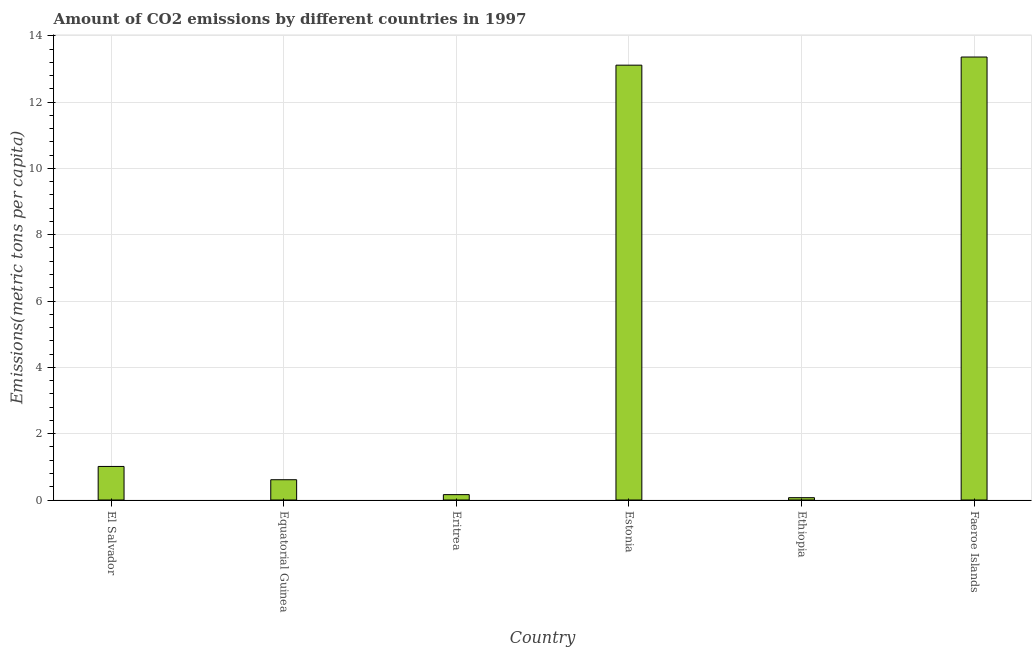What is the title of the graph?
Keep it short and to the point. Amount of CO2 emissions by different countries in 1997. What is the label or title of the X-axis?
Give a very brief answer. Country. What is the label or title of the Y-axis?
Your response must be concise. Emissions(metric tons per capita). What is the amount of co2 emissions in Estonia?
Keep it short and to the point. 13.11. Across all countries, what is the maximum amount of co2 emissions?
Your answer should be compact. 13.36. Across all countries, what is the minimum amount of co2 emissions?
Your answer should be compact. 0.07. In which country was the amount of co2 emissions maximum?
Provide a succinct answer. Faeroe Islands. In which country was the amount of co2 emissions minimum?
Provide a short and direct response. Ethiopia. What is the sum of the amount of co2 emissions?
Offer a terse response. 28.33. What is the difference between the amount of co2 emissions in Estonia and Ethiopia?
Provide a succinct answer. 13.04. What is the average amount of co2 emissions per country?
Offer a very short reply. 4.72. What is the median amount of co2 emissions?
Ensure brevity in your answer.  0.81. What is the ratio of the amount of co2 emissions in Estonia to that in Faeroe Islands?
Your answer should be compact. 0.98. Is the amount of co2 emissions in Equatorial Guinea less than that in Faeroe Islands?
Your response must be concise. Yes. What is the difference between the highest and the second highest amount of co2 emissions?
Ensure brevity in your answer.  0.25. Is the sum of the amount of co2 emissions in Eritrea and Estonia greater than the maximum amount of co2 emissions across all countries?
Your answer should be compact. No. What is the difference between the highest and the lowest amount of co2 emissions?
Your answer should be compact. 13.29. How many bars are there?
Offer a very short reply. 6. Are all the bars in the graph horizontal?
Ensure brevity in your answer.  No. How many countries are there in the graph?
Your response must be concise. 6. What is the difference between two consecutive major ticks on the Y-axis?
Your answer should be compact. 2. What is the Emissions(metric tons per capita) of El Salvador?
Give a very brief answer. 1.01. What is the Emissions(metric tons per capita) in Equatorial Guinea?
Offer a terse response. 0.61. What is the Emissions(metric tons per capita) of Eritrea?
Provide a succinct answer. 0.16. What is the Emissions(metric tons per capita) in Estonia?
Your answer should be compact. 13.11. What is the Emissions(metric tons per capita) of Ethiopia?
Your response must be concise. 0.07. What is the Emissions(metric tons per capita) of Faeroe Islands?
Keep it short and to the point. 13.36. What is the difference between the Emissions(metric tons per capita) in El Salvador and Equatorial Guinea?
Your response must be concise. 0.4. What is the difference between the Emissions(metric tons per capita) in El Salvador and Eritrea?
Your answer should be very brief. 0.85. What is the difference between the Emissions(metric tons per capita) in El Salvador and Estonia?
Give a very brief answer. -12.1. What is the difference between the Emissions(metric tons per capita) in El Salvador and Ethiopia?
Your response must be concise. 0.94. What is the difference between the Emissions(metric tons per capita) in El Salvador and Faeroe Islands?
Provide a short and direct response. -12.35. What is the difference between the Emissions(metric tons per capita) in Equatorial Guinea and Eritrea?
Give a very brief answer. 0.45. What is the difference between the Emissions(metric tons per capita) in Equatorial Guinea and Estonia?
Keep it short and to the point. -12.5. What is the difference between the Emissions(metric tons per capita) in Equatorial Guinea and Ethiopia?
Your answer should be very brief. 0.54. What is the difference between the Emissions(metric tons per capita) in Equatorial Guinea and Faeroe Islands?
Provide a succinct answer. -12.75. What is the difference between the Emissions(metric tons per capita) in Eritrea and Estonia?
Provide a short and direct response. -12.95. What is the difference between the Emissions(metric tons per capita) in Eritrea and Ethiopia?
Provide a short and direct response. 0.09. What is the difference between the Emissions(metric tons per capita) in Eritrea and Faeroe Islands?
Provide a succinct answer. -13.2. What is the difference between the Emissions(metric tons per capita) in Estonia and Ethiopia?
Ensure brevity in your answer.  13.04. What is the difference between the Emissions(metric tons per capita) in Estonia and Faeroe Islands?
Offer a terse response. -0.25. What is the difference between the Emissions(metric tons per capita) in Ethiopia and Faeroe Islands?
Ensure brevity in your answer.  -13.29. What is the ratio of the Emissions(metric tons per capita) in El Salvador to that in Equatorial Guinea?
Give a very brief answer. 1.66. What is the ratio of the Emissions(metric tons per capita) in El Salvador to that in Eritrea?
Offer a very short reply. 6.25. What is the ratio of the Emissions(metric tons per capita) in El Salvador to that in Estonia?
Offer a very short reply. 0.08. What is the ratio of the Emissions(metric tons per capita) in El Salvador to that in Ethiopia?
Ensure brevity in your answer.  14.43. What is the ratio of the Emissions(metric tons per capita) in El Salvador to that in Faeroe Islands?
Ensure brevity in your answer.  0.08. What is the ratio of the Emissions(metric tons per capita) in Equatorial Guinea to that in Eritrea?
Provide a short and direct response. 3.77. What is the ratio of the Emissions(metric tons per capita) in Equatorial Guinea to that in Estonia?
Make the answer very short. 0.05. What is the ratio of the Emissions(metric tons per capita) in Equatorial Guinea to that in Ethiopia?
Provide a succinct answer. 8.71. What is the ratio of the Emissions(metric tons per capita) in Equatorial Guinea to that in Faeroe Islands?
Your answer should be very brief. 0.05. What is the ratio of the Emissions(metric tons per capita) in Eritrea to that in Estonia?
Make the answer very short. 0.01. What is the ratio of the Emissions(metric tons per capita) in Eritrea to that in Ethiopia?
Your response must be concise. 2.31. What is the ratio of the Emissions(metric tons per capita) in Eritrea to that in Faeroe Islands?
Ensure brevity in your answer.  0.01. What is the ratio of the Emissions(metric tons per capita) in Estonia to that in Ethiopia?
Keep it short and to the point. 186.92. What is the ratio of the Emissions(metric tons per capita) in Ethiopia to that in Faeroe Islands?
Your response must be concise. 0.01. 